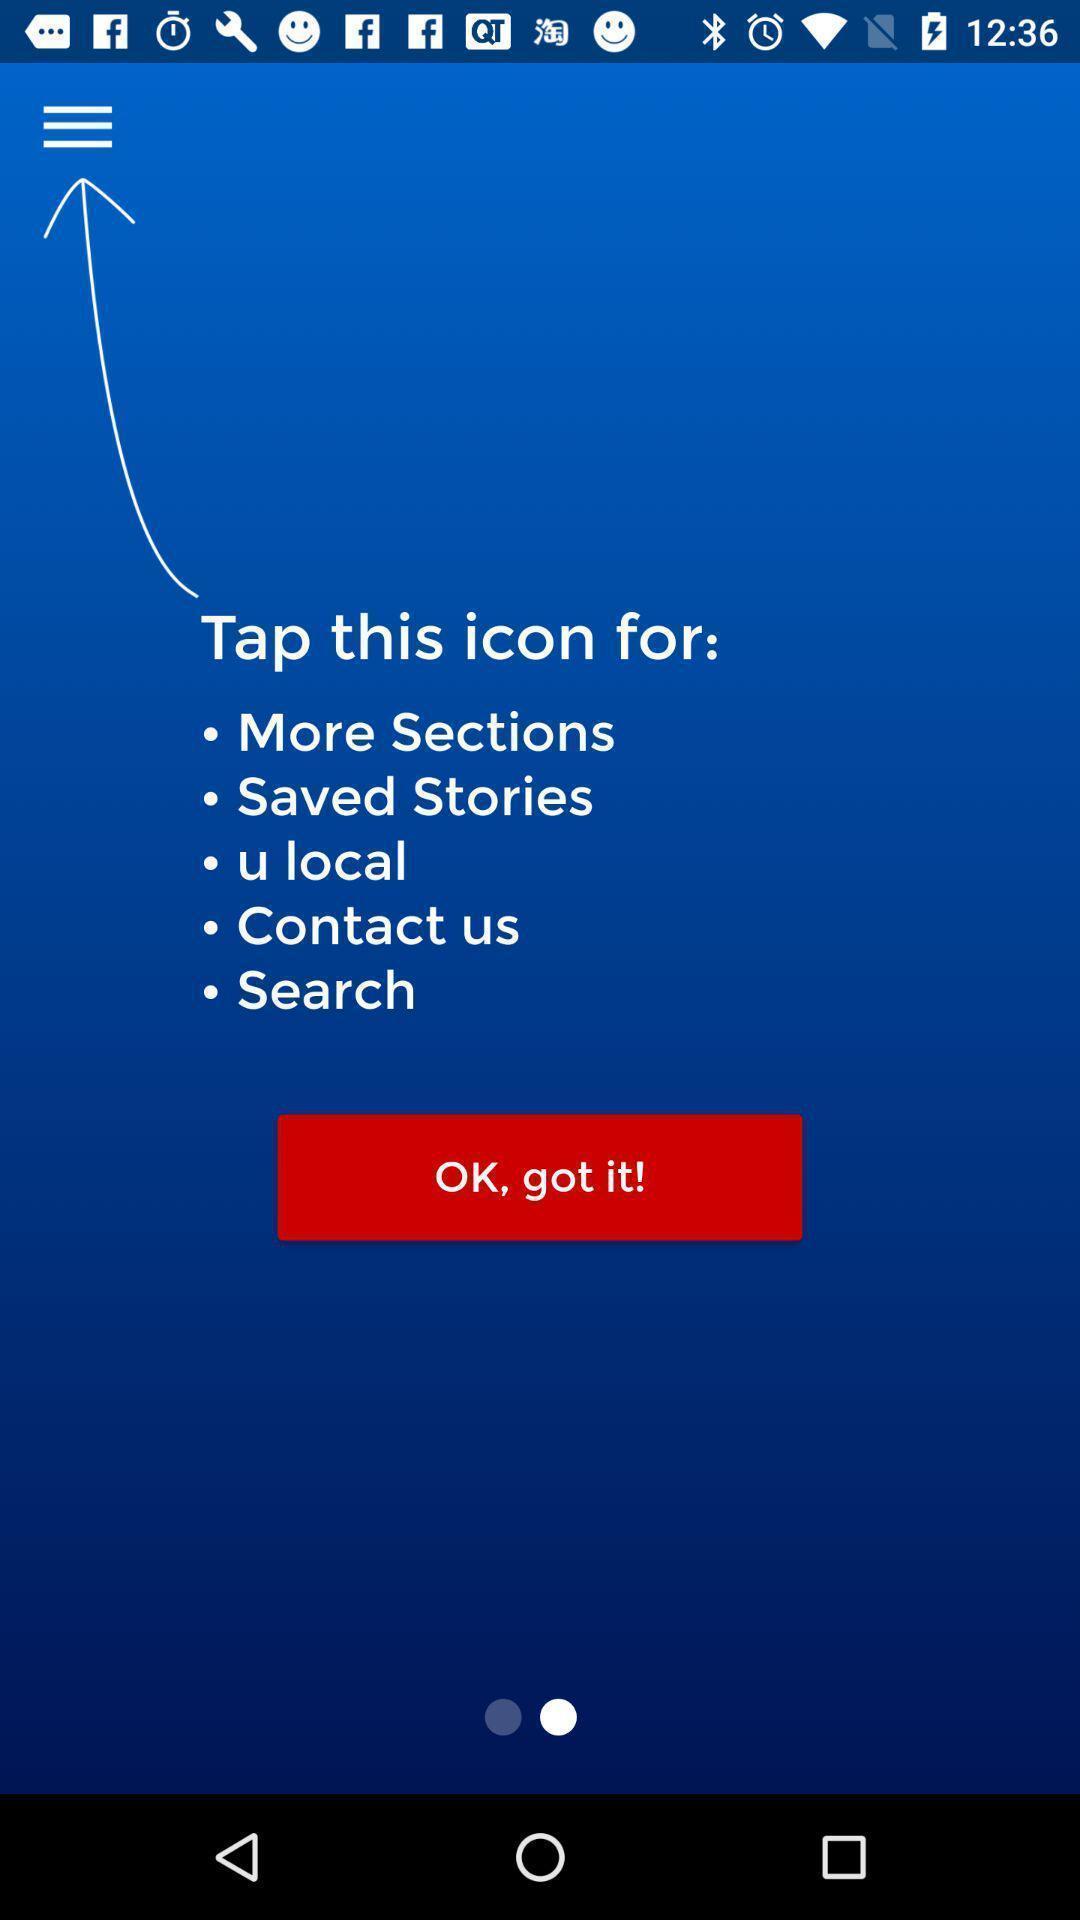Describe the key features of this screenshot. Welcome page. 